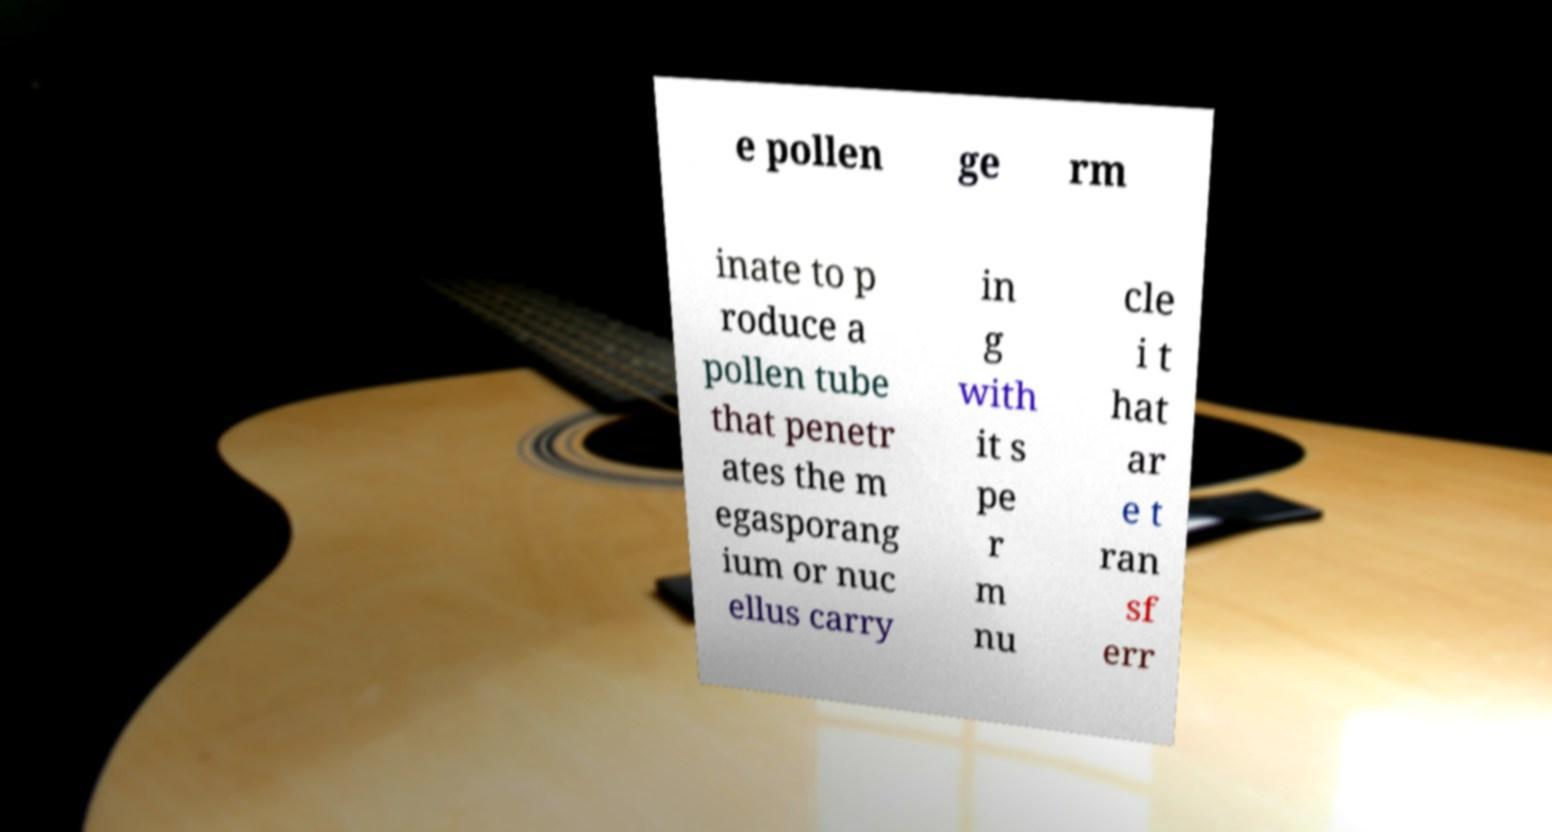For documentation purposes, I need the text within this image transcribed. Could you provide that? e pollen ge rm inate to p roduce a pollen tube that penetr ates the m egasporang ium or nuc ellus carry in g with it s pe r m nu cle i t hat ar e t ran sf err 